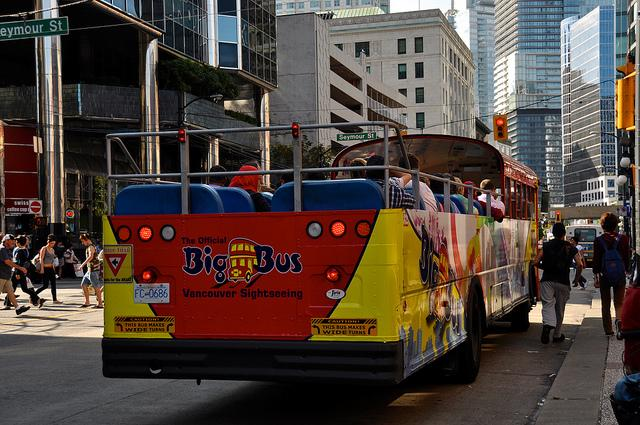What type of company owns the roofless bus? Please explain your reasoning. sightseeing. A company that gives tours of the city. 